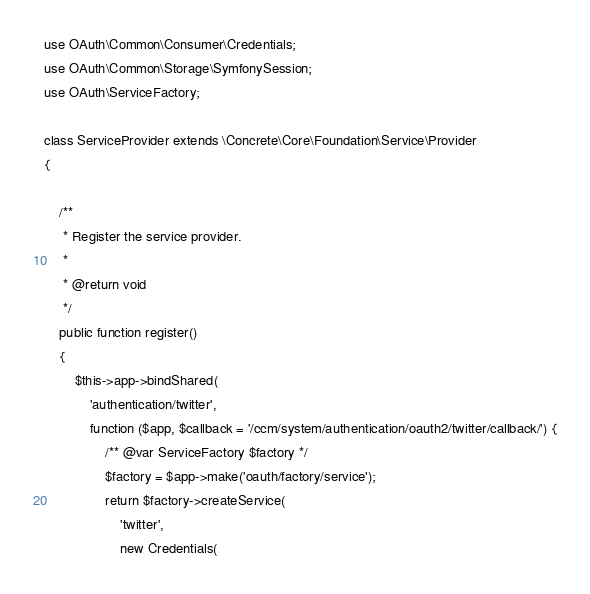Convert code to text. <code><loc_0><loc_0><loc_500><loc_500><_PHP_>
use OAuth\Common\Consumer\Credentials;
use OAuth\Common\Storage\SymfonySession;
use OAuth\ServiceFactory;

class ServiceProvider extends \Concrete\Core\Foundation\Service\Provider
{

    /**
     * Register the service provider.
     *
     * @return void
     */
    public function register()
    {
        $this->app->bindShared(
            'authentication/twitter',
            function ($app, $callback = '/ccm/system/authentication/oauth2/twitter/callback/') {
                /** @var ServiceFactory $factory */
                $factory = $app->make('oauth/factory/service');
                return $factory->createService(
                    'twitter',
                    new Credentials(</code> 